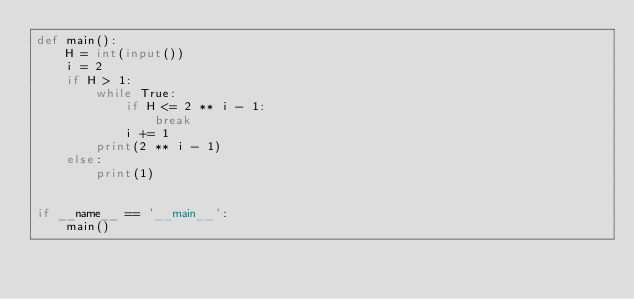<code> <loc_0><loc_0><loc_500><loc_500><_Python_>def main():
    H = int(input())
    i = 2
    if H > 1:
        while True:
            if H <= 2 ** i - 1:
                break
            i += 1
        print(2 ** i - 1)
    else:
        print(1)


if __name__ == '__main__':
    main()</code> 